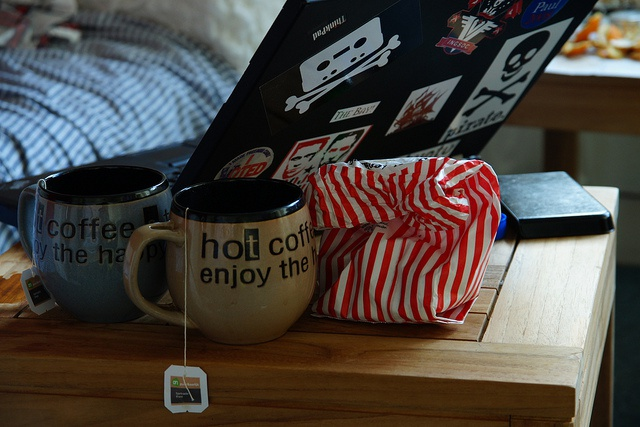Describe the objects in this image and their specific colors. I can see laptop in black, gray, and maroon tones, bed in black, gray, and lightblue tones, cup in black and gray tones, cup in black, darkblue, blue, and gray tones, and cell phone in black, lightblue, and gray tones in this image. 